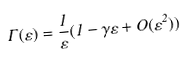<formula> <loc_0><loc_0><loc_500><loc_500>\Gamma ( \varepsilon ) = \frac { 1 } { \varepsilon } ( 1 - \gamma \varepsilon + O ( \varepsilon ^ { 2 } ) )</formula> 